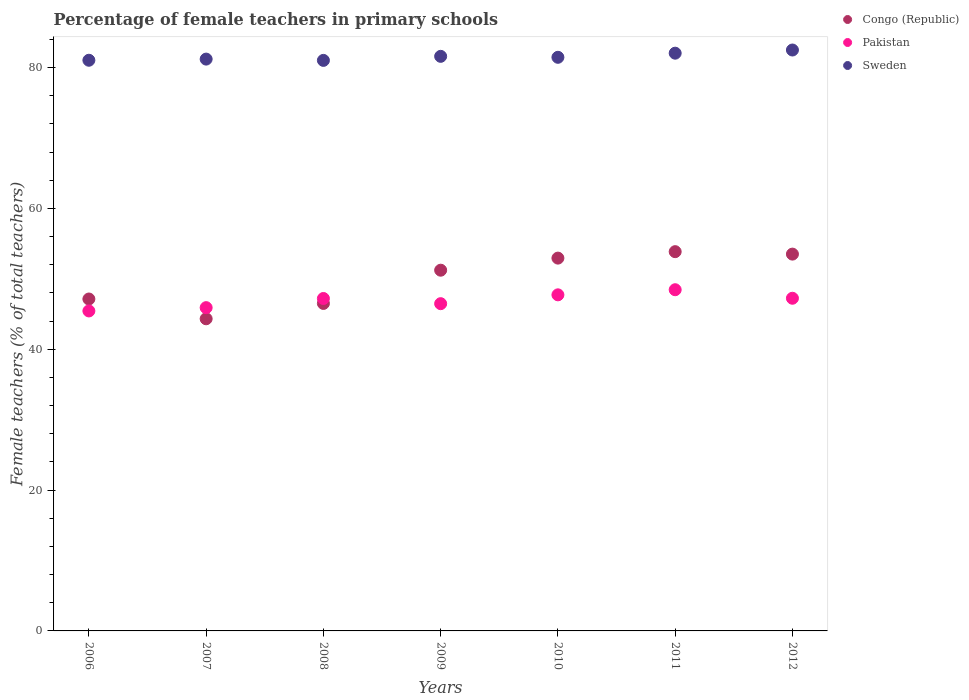What is the percentage of female teachers in Sweden in 2009?
Give a very brief answer. 81.59. Across all years, what is the maximum percentage of female teachers in Congo (Republic)?
Keep it short and to the point. 53.85. Across all years, what is the minimum percentage of female teachers in Pakistan?
Your answer should be compact. 45.44. What is the total percentage of female teachers in Sweden in the graph?
Keep it short and to the point. 570.81. What is the difference between the percentage of female teachers in Pakistan in 2006 and that in 2008?
Make the answer very short. -1.77. What is the difference between the percentage of female teachers in Pakistan in 2006 and the percentage of female teachers in Sweden in 2008?
Keep it short and to the point. -35.58. What is the average percentage of female teachers in Pakistan per year?
Ensure brevity in your answer.  46.92. In the year 2012, what is the difference between the percentage of female teachers in Sweden and percentage of female teachers in Congo (Republic)?
Your response must be concise. 28.98. In how many years, is the percentage of female teachers in Pakistan greater than 64 %?
Offer a terse response. 0. What is the ratio of the percentage of female teachers in Pakistan in 2006 to that in 2012?
Keep it short and to the point. 0.96. Is the percentage of female teachers in Pakistan in 2006 less than that in 2007?
Your answer should be compact. Yes. What is the difference between the highest and the second highest percentage of female teachers in Sweden?
Make the answer very short. 0.45. What is the difference between the highest and the lowest percentage of female teachers in Pakistan?
Your answer should be very brief. 3.01. Is the sum of the percentage of female teachers in Congo (Republic) in 2007 and 2008 greater than the maximum percentage of female teachers in Sweden across all years?
Offer a very short reply. Yes. Is it the case that in every year, the sum of the percentage of female teachers in Sweden and percentage of female teachers in Pakistan  is greater than the percentage of female teachers in Congo (Republic)?
Give a very brief answer. Yes. Does the percentage of female teachers in Sweden monotonically increase over the years?
Provide a short and direct response. No. How many dotlines are there?
Offer a very short reply. 3. What is the difference between two consecutive major ticks on the Y-axis?
Your answer should be compact. 20. Does the graph contain any zero values?
Your answer should be very brief. No. Does the graph contain grids?
Give a very brief answer. No. How many legend labels are there?
Provide a short and direct response. 3. What is the title of the graph?
Your answer should be compact. Percentage of female teachers in primary schools. What is the label or title of the X-axis?
Your answer should be very brief. Years. What is the label or title of the Y-axis?
Give a very brief answer. Female teachers (% of total teachers). What is the Female teachers (% of total teachers) in Congo (Republic) in 2006?
Keep it short and to the point. 47.13. What is the Female teachers (% of total teachers) in Pakistan in 2006?
Your answer should be compact. 45.44. What is the Female teachers (% of total teachers) in Sweden in 2006?
Your answer should be very brief. 81.03. What is the Female teachers (% of total teachers) in Congo (Republic) in 2007?
Give a very brief answer. 44.32. What is the Female teachers (% of total teachers) in Pakistan in 2007?
Give a very brief answer. 45.9. What is the Female teachers (% of total teachers) of Sweden in 2007?
Provide a succinct answer. 81.2. What is the Female teachers (% of total teachers) of Congo (Republic) in 2008?
Give a very brief answer. 46.5. What is the Female teachers (% of total teachers) in Pakistan in 2008?
Your answer should be compact. 47.2. What is the Female teachers (% of total teachers) in Sweden in 2008?
Your response must be concise. 81.01. What is the Female teachers (% of total teachers) of Congo (Republic) in 2009?
Keep it short and to the point. 51.22. What is the Female teachers (% of total teachers) of Pakistan in 2009?
Offer a terse response. 46.47. What is the Female teachers (% of total teachers) of Sweden in 2009?
Provide a succinct answer. 81.59. What is the Female teachers (% of total teachers) in Congo (Republic) in 2010?
Offer a terse response. 52.94. What is the Female teachers (% of total teachers) in Pakistan in 2010?
Keep it short and to the point. 47.72. What is the Female teachers (% of total teachers) in Sweden in 2010?
Your answer should be compact. 81.45. What is the Female teachers (% of total teachers) in Congo (Republic) in 2011?
Your answer should be compact. 53.85. What is the Female teachers (% of total teachers) in Pakistan in 2011?
Offer a terse response. 48.45. What is the Female teachers (% of total teachers) of Sweden in 2011?
Make the answer very short. 82.04. What is the Female teachers (% of total teachers) in Congo (Republic) in 2012?
Keep it short and to the point. 53.51. What is the Female teachers (% of total teachers) of Pakistan in 2012?
Offer a terse response. 47.24. What is the Female teachers (% of total teachers) of Sweden in 2012?
Offer a very short reply. 82.49. Across all years, what is the maximum Female teachers (% of total teachers) in Congo (Republic)?
Make the answer very short. 53.85. Across all years, what is the maximum Female teachers (% of total teachers) in Pakistan?
Ensure brevity in your answer.  48.45. Across all years, what is the maximum Female teachers (% of total teachers) in Sweden?
Ensure brevity in your answer.  82.49. Across all years, what is the minimum Female teachers (% of total teachers) in Congo (Republic)?
Give a very brief answer. 44.32. Across all years, what is the minimum Female teachers (% of total teachers) of Pakistan?
Keep it short and to the point. 45.44. Across all years, what is the minimum Female teachers (% of total teachers) in Sweden?
Your answer should be compact. 81.01. What is the total Female teachers (% of total teachers) of Congo (Republic) in the graph?
Your response must be concise. 349.48. What is the total Female teachers (% of total teachers) of Pakistan in the graph?
Offer a very short reply. 328.42. What is the total Female teachers (% of total teachers) in Sweden in the graph?
Your answer should be compact. 570.81. What is the difference between the Female teachers (% of total teachers) in Congo (Republic) in 2006 and that in 2007?
Your answer should be very brief. 2.81. What is the difference between the Female teachers (% of total teachers) in Pakistan in 2006 and that in 2007?
Offer a terse response. -0.47. What is the difference between the Female teachers (% of total teachers) in Sweden in 2006 and that in 2007?
Your answer should be very brief. -0.16. What is the difference between the Female teachers (% of total teachers) in Congo (Republic) in 2006 and that in 2008?
Provide a short and direct response. 0.63. What is the difference between the Female teachers (% of total teachers) of Pakistan in 2006 and that in 2008?
Give a very brief answer. -1.77. What is the difference between the Female teachers (% of total teachers) in Sweden in 2006 and that in 2008?
Provide a succinct answer. 0.02. What is the difference between the Female teachers (% of total teachers) of Congo (Republic) in 2006 and that in 2009?
Give a very brief answer. -4.09. What is the difference between the Female teachers (% of total teachers) in Pakistan in 2006 and that in 2009?
Ensure brevity in your answer.  -1.03. What is the difference between the Female teachers (% of total teachers) in Sweden in 2006 and that in 2009?
Your answer should be very brief. -0.56. What is the difference between the Female teachers (% of total teachers) of Congo (Republic) in 2006 and that in 2010?
Ensure brevity in your answer.  -5.81. What is the difference between the Female teachers (% of total teachers) of Pakistan in 2006 and that in 2010?
Your answer should be very brief. -2.29. What is the difference between the Female teachers (% of total teachers) in Sweden in 2006 and that in 2010?
Keep it short and to the point. -0.42. What is the difference between the Female teachers (% of total teachers) in Congo (Republic) in 2006 and that in 2011?
Make the answer very short. -6.72. What is the difference between the Female teachers (% of total teachers) of Pakistan in 2006 and that in 2011?
Your response must be concise. -3.01. What is the difference between the Female teachers (% of total teachers) in Sweden in 2006 and that in 2011?
Provide a short and direct response. -1. What is the difference between the Female teachers (% of total teachers) in Congo (Republic) in 2006 and that in 2012?
Provide a succinct answer. -6.37. What is the difference between the Female teachers (% of total teachers) of Pakistan in 2006 and that in 2012?
Offer a very short reply. -1.8. What is the difference between the Female teachers (% of total teachers) of Sweden in 2006 and that in 2012?
Keep it short and to the point. -1.45. What is the difference between the Female teachers (% of total teachers) of Congo (Republic) in 2007 and that in 2008?
Keep it short and to the point. -2.18. What is the difference between the Female teachers (% of total teachers) of Pakistan in 2007 and that in 2008?
Make the answer very short. -1.3. What is the difference between the Female teachers (% of total teachers) of Sweden in 2007 and that in 2008?
Your response must be concise. 0.18. What is the difference between the Female teachers (% of total teachers) in Congo (Republic) in 2007 and that in 2009?
Make the answer very short. -6.9. What is the difference between the Female teachers (% of total teachers) in Pakistan in 2007 and that in 2009?
Provide a short and direct response. -0.56. What is the difference between the Female teachers (% of total teachers) of Sweden in 2007 and that in 2009?
Your answer should be very brief. -0.39. What is the difference between the Female teachers (% of total teachers) of Congo (Republic) in 2007 and that in 2010?
Your answer should be very brief. -8.61. What is the difference between the Female teachers (% of total teachers) of Pakistan in 2007 and that in 2010?
Give a very brief answer. -1.82. What is the difference between the Female teachers (% of total teachers) of Sweden in 2007 and that in 2010?
Your answer should be very brief. -0.26. What is the difference between the Female teachers (% of total teachers) of Congo (Republic) in 2007 and that in 2011?
Provide a short and direct response. -9.53. What is the difference between the Female teachers (% of total teachers) in Pakistan in 2007 and that in 2011?
Ensure brevity in your answer.  -2.54. What is the difference between the Female teachers (% of total teachers) in Sweden in 2007 and that in 2011?
Make the answer very short. -0.84. What is the difference between the Female teachers (% of total teachers) in Congo (Republic) in 2007 and that in 2012?
Provide a short and direct response. -9.18. What is the difference between the Female teachers (% of total teachers) in Pakistan in 2007 and that in 2012?
Keep it short and to the point. -1.33. What is the difference between the Female teachers (% of total teachers) in Sweden in 2007 and that in 2012?
Your answer should be compact. -1.29. What is the difference between the Female teachers (% of total teachers) of Congo (Republic) in 2008 and that in 2009?
Provide a succinct answer. -4.72. What is the difference between the Female teachers (% of total teachers) of Pakistan in 2008 and that in 2009?
Offer a very short reply. 0.74. What is the difference between the Female teachers (% of total teachers) of Sweden in 2008 and that in 2009?
Offer a terse response. -0.57. What is the difference between the Female teachers (% of total teachers) of Congo (Republic) in 2008 and that in 2010?
Your answer should be very brief. -6.44. What is the difference between the Female teachers (% of total teachers) of Pakistan in 2008 and that in 2010?
Offer a very short reply. -0.52. What is the difference between the Female teachers (% of total teachers) in Sweden in 2008 and that in 2010?
Make the answer very short. -0.44. What is the difference between the Female teachers (% of total teachers) in Congo (Republic) in 2008 and that in 2011?
Offer a very short reply. -7.35. What is the difference between the Female teachers (% of total teachers) of Pakistan in 2008 and that in 2011?
Ensure brevity in your answer.  -1.25. What is the difference between the Female teachers (% of total teachers) in Sweden in 2008 and that in 2011?
Keep it short and to the point. -1.02. What is the difference between the Female teachers (% of total teachers) in Congo (Republic) in 2008 and that in 2012?
Provide a short and direct response. -7. What is the difference between the Female teachers (% of total teachers) in Pakistan in 2008 and that in 2012?
Ensure brevity in your answer.  -0.03. What is the difference between the Female teachers (% of total teachers) in Sweden in 2008 and that in 2012?
Your response must be concise. -1.47. What is the difference between the Female teachers (% of total teachers) of Congo (Republic) in 2009 and that in 2010?
Make the answer very short. -1.72. What is the difference between the Female teachers (% of total teachers) in Pakistan in 2009 and that in 2010?
Offer a very short reply. -1.26. What is the difference between the Female teachers (% of total teachers) in Sweden in 2009 and that in 2010?
Your answer should be compact. 0.14. What is the difference between the Female teachers (% of total teachers) in Congo (Republic) in 2009 and that in 2011?
Make the answer very short. -2.63. What is the difference between the Female teachers (% of total teachers) of Pakistan in 2009 and that in 2011?
Offer a very short reply. -1.98. What is the difference between the Female teachers (% of total teachers) of Sweden in 2009 and that in 2011?
Give a very brief answer. -0.45. What is the difference between the Female teachers (% of total teachers) of Congo (Republic) in 2009 and that in 2012?
Provide a succinct answer. -2.28. What is the difference between the Female teachers (% of total teachers) of Pakistan in 2009 and that in 2012?
Your answer should be compact. -0.77. What is the difference between the Female teachers (% of total teachers) in Sweden in 2009 and that in 2012?
Keep it short and to the point. -0.9. What is the difference between the Female teachers (% of total teachers) in Congo (Republic) in 2010 and that in 2011?
Give a very brief answer. -0.92. What is the difference between the Female teachers (% of total teachers) in Pakistan in 2010 and that in 2011?
Make the answer very short. -0.73. What is the difference between the Female teachers (% of total teachers) in Sweden in 2010 and that in 2011?
Make the answer very short. -0.58. What is the difference between the Female teachers (% of total teachers) in Congo (Republic) in 2010 and that in 2012?
Offer a very short reply. -0.57. What is the difference between the Female teachers (% of total teachers) of Pakistan in 2010 and that in 2012?
Your response must be concise. 0.49. What is the difference between the Female teachers (% of total teachers) of Sweden in 2010 and that in 2012?
Your answer should be compact. -1.04. What is the difference between the Female teachers (% of total teachers) in Congo (Republic) in 2011 and that in 2012?
Keep it short and to the point. 0.35. What is the difference between the Female teachers (% of total teachers) of Pakistan in 2011 and that in 2012?
Keep it short and to the point. 1.21. What is the difference between the Female teachers (% of total teachers) of Sweden in 2011 and that in 2012?
Keep it short and to the point. -0.45. What is the difference between the Female teachers (% of total teachers) of Congo (Republic) in 2006 and the Female teachers (% of total teachers) of Pakistan in 2007?
Ensure brevity in your answer.  1.23. What is the difference between the Female teachers (% of total teachers) of Congo (Republic) in 2006 and the Female teachers (% of total teachers) of Sweden in 2007?
Your answer should be very brief. -34.07. What is the difference between the Female teachers (% of total teachers) in Pakistan in 2006 and the Female teachers (% of total teachers) in Sweden in 2007?
Keep it short and to the point. -35.76. What is the difference between the Female teachers (% of total teachers) in Congo (Republic) in 2006 and the Female teachers (% of total teachers) in Pakistan in 2008?
Provide a short and direct response. -0.07. What is the difference between the Female teachers (% of total teachers) in Congo (Republic) in 2006 and the Female teachers (% of total teachers) in Sweden in 2008?
Give a very brief answer. -33.88. What is the difference between the Female teachers (% of total teachers) in Pakistan in 2006 and the Female teachers (% of total teachers) in Sweden in 2008?
Your answer should be very brief. -35.58. What is the difference between the Female teachers (% of total teachers) in Congo (Republic) in 2006 and the Female teachers (% of total teachers) in Pakistan in 2009?
Your answer should be compact. 0.66. What is the difference between the Female teachers (% of total teachers) in Congo (Republic) in 2006 and the Female teachers (% of total teachers) in Sweden in 2009?
Your answer should be very brief. -34.46. What is the difference between the Female teachers (% of total teachers) of Pakistan in 2006 and the Female teachers (% of total teachers) of Sweden in 2009?
Ensure brevity in your answer.  -36.15. What is the difference between the Female teachers (% of total teachers) of Congo (Republic) in 2006 and the Female teachers (% of total teachers) of Pakistan in 2010?
Provide a short and direct response. -0.59. What is the difference between the Female teachers (% of total teachers) of Congo (Republic) in 2006 and the Female teachers (% of total teachers) of Sweden in 2010?
Offer a very short reply. -34.32. What is the difference between the Female teachers (% of total teachers) of Pakistan in 2006 and the Female teachers (% of total teachers) of Sweden in 2010?
Give a very brief answer. -36.02. What is the difference between the Female teachers (% of total teachers) of Congo (Republic) in 2006 and the Female teachers (% of total teachers) of Pakistan in 2011?
Make the answer very short. -1.32. What is the difference between the Female teachers (% of total teachers) in Congo (Republic) in 2006 and the Female teachers (% of total teachers) in Sweden in 2011?
Provide a succinct answer. -34.91. What is the difference between the Female teachers (% of total teachers) in Pakistan in 2006 and the Female teachers (% of total teachers) in Sweden in 2011?
Give a very brief answer. -36.6. What is the difference between the Female teachers (% of total teachers) in Congo (Republic) in 2006 and the Female teachers (% of total teachers) in Pakistan in 2012?
Offer a terse response. -0.11. What is the difference between the Female teachers (% of total teachers) of Congo (Republic) in 2006 and the Female teachers (% of total teachers) of Sweden in 2012?
Your response must be concise. -35.36. What is the difference between the Female teachers (% of total teachers) in Pakistan in 2006 and the Female teachers (% of total teachers) in Sweden in 2012?
Your answer should be very brief. -37.05. What is the difference between the Female teachers (% of total teachers) in Congo (Republic) in 2007 and the Female teachers (% of total teachers) in Pakistan in 2008?
Offer a terse response. -2.88. What is the difference between the Female teachers (% of total teachers) in Congo (Republic) in 2007 and the Female teachers (% of total teachers) in Sweden in 2008?
Offer a terse response. -36.69. What is the difference between the Female teachers (% of total teachers) of Pakistan in 2007 and the Female teachers (% of total teachers) of Sweden in 2008?
Provide a succinct answer. -35.11. What is the difference between the Female teachers (% of total teachers) of Congo (Republic) in 2007 and the Female teachers (% of total teachers) of Pakistan in 2009?
Give a very brief answer. -2.15. What is the difference between the Female teachers (% of total teachers) in Congo (Republic) in 2007 and the Female teachers (% of total teachers) in Sweden in 2009?
Offer a very short reply. -37.27. What is the difference between the Female teachers (% of total teachers) in Pakistan in 2007 and the Female teachers (% of total teachers) in Sweden in 2009?
Your answer should be compact. -35.68. What is the difference between the Female teachers (% of total teachers) in Congo (Republic) in 2007 and the Female teachers (% of total teachers) in Pakistan in 2010?
Keep it short and to the point. -3.4. What is the difference between the Female teachers (% of total teachers) of Congo (Republic) in 2007 and the Female teachers (% of total teachers) of Sweden in 2010?
Your answer should be compact. -37.13. What is the difference between the Female teachers (% of total teachers) of Pakistan in 2007 and the Female teachers (% of total teachers) of Sweden in 2010?
Make the answer very short. -35.55. What is the difference between the Female teachers (% of total teachers) in Congo (Republic) in 2007 and the Female teachers (% of total teachers) in Pakistan in 2011?
Your answer should be compact. -4.13. What is the difference between the Female teachers (% of total teachers) in Congo (Republic) in 2007 and the Female teachers (% of total teachers) in Sweden in 2011?
Your answer should be compact. -37.71. What is the difference between the Female teachers (% of total teachers) in Pakistan in 2007 and the Female teachers (% of total teachers) in Sweden in 2011?
Give a very brief answer. -36.13. What is the difference between the Female teachers (% of total teachers) of Congo (Republic) in 2007 and the Female teachers (% of total teachers) of Pakistan in 2012?
Provide a succinct answer. -2.92. What is the difference between the Female teachers (% of total teachers) in Congo (Republic) in 2007 and the Female teachers (% of total teachers) in Sweden in 2012?
Your response must be concise. -38.16. What is the difference between the Female teachers (% of total teachers) in Pakistan in 2007 and the Female teachers (% of total teachers) in Sweden in 2012?
Your response must be concise. -36.58. What is the difference between the Female teachers (% of total teachers) in Congo (Republic) in 2008 and the Female teachers (% of total teachers) in Pakistan in 2009?
Ensure brevity in your answer.  0.03. What is the difference between the Female teachers (% of total teachers) in Congo (Republic) in 2008 and the Female teachers (% of total teachers) in Sweden in 2009?
Provide a short and direct response. -35.09. What is the difference between the Female teachers (% of total teachers) of Pakistan in 2008 and the Female teachers (% of total teachers) of Sweden in 2009?
Ensure brevity in your answer.  -34.39. What is the difference between the Female teachers (% of total teachers) of Congo (Republic) in 2008 and the Female teachers (% of total teachers) of Pakistan in 2010?
Provide a short and direct response. -1.22. What is the difference between the Female teachers (% of total teachers) of Congo (Republic) in 2008 and the Female teachers (% of total teachers) of Sweden in 2010?
Offer a very short reply. -34.95. What is the difference between the Female teachers (% of total teachers) in Pakistan in 2008 and the Female teachers (% of total teachers) in Sweden in 2010?
Offer a very short reply. -34.25. What is the difference between the Female teachers (% of total teachers) of Congo (Republic) in 2008 and the Female teachers (% of total teachers) of Pakistan in 2011?
Make the answer very short. -1.95. What is the difference between the Female teachers (% of total teachers) in Congo (Republic) in 2008 and the Female teachers (% of total teachers) in Sweden in 2011?
Offer a terse response. -35.53. What is the difference between the Female teachers (% of total teachers) in Pakistan in 2008 and the Female teachers (% of total teachers) in Sweden in 2011?
Provide a succinct answer. -34.83. What is the difference between the Female teachers (% of total teachers) of Congo (Republic) in 2008 and the Female teachers (% of total teachers) of Pakistan in 2012?
Give a very brief answer. -0.74. What is the difference between the Female teachers (% of total teachers) of Congo (Republic) in 2008 and the Female teachers (% of total teachers) of Sweden in 2012?
Offer a very short reply. -35.98. What is the difference between the Female teachers (% of total teachers) in Pakistan in 2008 and the Female teachers (% of total teachers) in Sweden in 2012?
Ensure brevity in your answer.  -35.28. What is the difference between the Female teachers (% of total teachers) of Congo (Republic) in 2009 and the Female teachers (% of total teachers) of Pakistan in 2010?
Offer a terse response. 3.5. What is the difference between the Female teachers (% of total teachers) of Congo (Republic) in 2009 and the Female teachers (% of total teachers) of Sweden in 2010?
Keep it short and to the point. -30.23. What is the difference between the Female teachers (% of total teachers) of Pakistan in 2009 and the Female teachers (% of total teachers) of Sweden in 2010?
Keep it short and to the point. -34.98. What is the difference between the Female teachers (% of total teachers) of Congo (Republic) in 2009 and the Female teachers (% of total teachers) of Pakistan in 2011?
Offer a very short reply. 2.77. What is the difference between the Female teachers (% of total teachers) in Congo (Republic) in 2009 and the Female teachers (% of total teachers) in Sweden in 2011?
Provide a short and direct response. -30.82. What is the difference between the Female teachers (% of total teachers) of Pakistan in 2009 and the Female teachers (% of total teachers) of Sweden in 2011?
Your answer should be very brief. -35.57. What is the difference between the Female teachers (% of total teachers) in Congo (Republic) in 2009 and the Female teachers (% of total teachers) in Pakistan in 2012?
Ensure brevity in your answer.  3.98. What is the difference between the Female teachers (% of total teachers) in Congo (Republic) in 2009 and the Female teachers (% of total teachers) in Sweden in 2012?
Your answer should be compact. -31.27. What is the difference between the Female teachers (% of total teachers) in Pakistan in 2009 and the Female teachers (% of total teachers) in Sweden in 2012?
Ensure brevity in your answer.  -36.02. What is the difference between the Female teachers (% of total teachers) in Congo (Republic) in 2010 and the Female teachers (% of total teachers) in Pakistan in 2011?
Make the answer very short. 4.49. What is the difference between the Female teachers (% of total teachers) of Congo (Republic) in 2010 and the Female teachers (% of total teachers) of Sweden in 2011?
Offer a terse response. -29.1. What is the difference between the Female teachers (% of total teachers) in Pakistan in 2010 and the Female teachers (% of total teachers) in Sweden in 2011?
Your response must be concise. -34.31. What is the difference between the Female teachers (% of total teachers) in Congo (Republic) in 2010 and the Female teachers (% of total teachers) in Pakistan in 2012?
Keep it short and to the point. 5.7. What is the difference between the Female teachers (% of total teachers) of Congo (Republic) in 2010 and the Female teachers (% of total teachers) of Sweden in 2012?
Keep it short and to the point. -29.55. What is the difference between the Female teachers (% of total teachers) of Pakistan in 2010 and the Female teachers (% of total teachers) of Sweden in 2012?
Keep it short and to the point. -34.76. What is the difference between the Female teachers (% of total teachers) in Congo (Republic) in 2011 and the Female teachers (% of total teachers) in Pakistan in 2012?
Make the answer very short. 6.62. What is the difference between the Female teachers (% of total teachers) in Congo (Republic) in 2011 and the Female teachers (% of total teachers) in Sweden in 2012?
Your answer should be very brief. -28.63. What is the difference between the Female teachers (% of total teachers) of Pakistan in 2011 and the Female teachers (% of total teachers) of Sweden in 2012?
Ensure brevity in your answer.  -34.04. What is the average Female teachers (% of total teachers) of Congo (Republic) per year?
Ensure brevity in your answer.  49.93. What is the average Female teachers (% of total teachers) of Pakistan per year?
Give a very brief answer. 46.92. What is the average Female teachers (% of total teachers) in Sweden per year?
Provide a succinct answer. 81.54. In the year 2006, what is the difference between the Female teachers (% of total teachers) in Congo (Republic) and Female teachers (% of total teachers) in Pakistan?
Your response must be concise. 1.7. In the year 2006, what is the difference between the Female teachers (% of total teachers) of Congo (Republic) and Female teachers (% of total teachers) of Sweden?
Your answer should be compact. -33.9. In the year 2006, what is the difference between the Female teachers (% of total teachers) of Pakistan and Female teachers (% of total teachers) of Sweden?
Your answer should be compact. -35.6. In the year 2007, what is the difference between the Female teachers (% of total teachers) of Congo (Republic) and Female teachers (% of total teachers) of Pakistan?
Your answer should be very brief. -1.58. In the year 2007, what is the difference between the Female teachers (% of total teachers) in Congo (Republic) and Female teachers (% of total teachers) in Sweden?
Offer a terse response. -36.87. In the year 2007, what is the difference between the Female teachers (% of total teachers) in Pakistan and Female teachers (% of total teachers) in Sweden?
Your response must be concise. -35.29. In the year 2008, what is the difference between the Female teachers (% of total teachers) of Congo (Republic) and Female teachers (% of total teachers) of Pakistan?
Your answer should be compact. -0.7. In the year 2008, what is the difference between the Female teachers (% of total teachers) of Congo (Republic) and Female teachers (% of total teachers) of Sweden?
Ensure brevity in your answer.  -34.51. In the year 2008, what is the difference between the Female teachers (% of total teachers) in Pakistan and Female teachers (% of total teachers) in Sweden?
Provide a succinct answer. -33.81. In the year 2009, what is the difference between the Female teachers (% of total teachers) of Congo (Republic) and Female teachers (% of total teachers) of Pakistan?
Ensure brevity in your answer.  4.75. In the year 2009, what is the difference between the Female teachers (% of total teachers) of Congo (Republic) and Female teachers (% of total teachers) of Sweden?
Your response must be concise. -30.37. In the year 2009, what is the difference between the Female teachers (% of total teachers) of Pakistan and Female teachers (% of total teachers) of Sweden?
Your response must be concise. -35.12. In the year 2010, what is the difference between the Female teachers (% of total teachers) in Congo (Republic) and Female teachers (% of total teachers) in Pakistan?
Ensure brevity in your answer.  5.21. In the year 2010, what is the difference between the Female teachers (% of total teachers) of Congo (Republic) and Female teachers (% of total teachers) of Sweden?
Give a very brief answer. -28.51. In the year 2010, what is the difference between the Female teachers (% of total teachers) of Pakistan and Female teachers (% of total teachers) of Sweden?
Your answer should be very brief. -33.73. In the year 2011, what is the difference between the Female teachers (% of total teachers) of Congo (Republic) and Female teachers (% of total teachers) of Pakistan?
Ensure brevity in your answer.  5.41. In the year 2011, what is the difference between the Female teachers (% of total teachers) in Congo (Republic) and Female teachers (% of total teachers) in Sweden?
Your answer should be very brief. -28.18. In the year 2011, what is the difference between the Female teachers (% of total teachers) of Pakistan and Female teachers (% of total teachers) of Sweden?
Offer a terse response. -33.59. In the year 2012, what is the difference between the Female teachers (% of total teachers) in Congo (Republic) and Female teachers (% of total teachers) in Pakistan?
Offer a terse response. 6.27. In the year 2012, what is the difference between the Female teachers (% of total teachers) in Congo (Republic) and Female teachers (% of total teachers) in Sweden?
Provide a short and direct response. -28.98. In the year 2012, what is the difference between the Female teachers (% of total teachers) of Pakistan and Female teachers (% of total teachers) of Sweden?
Keep it short and to the point. -35.25. What is the ratio of the Female teachers (% of total teachers) in Congo (Republic) in 2006 to that in 2007?
Your answer should be compact. 1.06. What is the ratio of the Female teachers (% of total teachers) of Congo (Republic) in 2006 to that in 2008?
Make the answer very short. 1.01. What is the ratio of the Female teachers (% of total teachers) of Pakistan in 2006 to that in 2008?
Your answer should be very brief. 0.96. What is the ratio of the Female teachers (% of total teachers) in Congo (Republic) in 2006 to that in 2009?
Give a very brief answer. 0.92. What is the ratio of the Female teachers (% of total teachers) of Pakistan in 2006 to that in 2009?
Offer a terse response. 0.98. What is the ratio of the Female teachers (% of total teachers) of Congo (Republic) in 2006 to that in 2010?
Make the answer very short. 0.89. What is the ratio of the Female teachers (% of total teachers) of Pakistan in 2006 to that in 2010?
Keep it short and to the point. 0.95. What is the ratio of the Female teachers (% of total teachers) of Sweden in 2006 to that in 2010?
Provide a short and direct response. 0.99. What is the ratio of the Female teachers (% of total teachers) of Congo (Republic) in 2006 to that in 2011?
Offer a terse response. 0.88. What is the ratio of the Female teachers (% of total teachers) of Pakistan in 2006 to that in 2011?
Offer a very short reply. 0.94. What is the ratio of the Female teachers (% of total teachers) in Sweden in 2006 to that in 2011?
Provide a short and direct response. 0.99. What is the ratio of the Female teachers (% of total teachers) of Congo (Republic) in 2006 to that in 2012?
Make the answer very short. 0.88. What is the ratio of the Female teachers (% of total teachers) of Pakistan in 2006 to that in 2012?
Offer a very short reply. 0.96. What is the ratio of the Female teachers (% of total teachers) in Sweden in 2006 to that in 2012?
Keep it short and to the point. 0.98. What is the ratio of the Female teachers (% of total teachers) of Congo (Republic) in 2007 to that in 2008?
Ensure brevity in your answer.  0.95. What is the ratio of the Female teachers (% of total teachers) of Pakistan in 2007 to that in 2008?
Provide a short and direct response. 0.97. What is the ratio of the Female teachers (% of total teachers) in Sweden in 2007 to that in 2008?
Provide a short and direct response. 1. What is the ratio of the Female teachers (% of total teachers) in Congo (Republic) in 2007 to that in 2009?
Ensure brevity in your answer.  0.87. What is the ratio of the Female teachers (% of total teachers) in Pakistan in 2007 to that in 2009?
Ensure brevity in your answer.  0.99. What is the ratio of the Female teachers (% of total teachers) in Sweden in 2007 to that in 2009?
Provide a short and direct response. 1. What is the ratio of the Female teachers (% of total teachers) in Congo (Republic) in 2007 to that in 2010?
Provide a short and direct response. 0.84. What is the ratio of the Female teachers (% of total teachers) of Pakistan in 2007 to that in 2010?
Offer a very short reply. 0.96. What is the ratio of the Female teachers (% of total teachers) of Sweden in 2007 to that in 2010?
Offer a terse response. 1. What is the ratio of the Female teachers (% of total teachers) of Congo (Republic) in 2007 to that in 2011?
Keep it short and to the point. 0.82. What is the ratio of the Female teachers (% of total teachers) in Pakistan in 2007 to that in 2011?
Provide a short and direct response. 0.95. What is the ratio of the Female teachers (% of total teachers) in Congo (Republic) in 2007 to that in 2012?
Your response must be concise. 0.83. What is the ratio of the Female teachers (% of total teachers) in Pakistan in 2007 to that in 2012?
Keep it short and to the point. 0.97. What is the ratio of the Female teachers (% of total teachers) in Sweden in 2007 to that in 2012?
Your answer should be compact. 0.98. What is the ratio of the Female teachers (% of total teachers) in Congo (Republic) in 2008 to that in 2009?
Provide a short and direct response. 0.91. What is the ratio of the Female teachers (% of total teachers) of Pakistan in 2008 to that in 2009?
Keep it short and to the point. 1.02. What is the ratio of the Female teachers (% of total teachers) of Sweden in 2008 to that in 2009?
Offer a terse response. 0.99. What is the ratio of the Female teachers (% of total teachers) of Congo (Republic) in 2008 to that in 2010?
Ensure brevity in your answer.  0.88. What is the ratio of the Female teachers (% of total teachers) of Congo (Republic) in 2008 to that in 2011?
Provide a short and direct response. 0.86. What is the ratio of the Female teachers (% of total teachers) in Pakistan in 2008 to that in 2011?
Your answer should be compact. 0.97. What is the ratio of the Female teachers (% of total teachers) in Sweden in 2008 to that in 2011?
Provide a succinct answer. 0.99. What is the ratio of the Female teachers (% of total teachers) of Congo (Republic) in 2008 to that in 2012?
Offer a very short reply. 0.87. What is the ratio of the Female teachers (% of total teachers) of Sweden in 2008 to that in 2012?
Your answer should be compact. 0.98. What is the ratio of the Female teachers (% of total teachers) of Congo (Republic) in 2009 to that in 2010?
Ensure brevity in your answer.  0.97. What is the ratio of the Female teachers (% of total teachers) in Pakistan in 2009 to that in 2010?
Your response must be concise. 0.97. What is the ratio of the Female teachers (% of total teachers) of Congo (Republic) in 2009 to that in 2011?
Provide a succinct answer. 0.95. What is the ratio of the Female teachers (% of total teachers) in Pakistan in 2009 to that in 2011?
Ensure brevity in your answer.  0.96. What is the ratio of the Female teachers (% of total teachers) of Sweden in 2009 to that in 2011?
Make the answer very short. 0.99. What is the ratio of the Female teachers (% of total teachers) in Congo (Republic) in 2009 to that in 2012?
Provide a short and direct response. 0.96. What is the ratio of the Female teachers (% of total teachers) in Pakistan in 2009 to that in 2012?
Your answer should be very brief. 0.98. What is the ratio of the Female teachers (% of total teachers) of Sweden in 2009 to that in 2012?
Make the answer very short. 0.99. What is the ratio of the Female teachers (% of total teachers) in Pakistan in 2010 to that in 2011?
Keep it short and to the point. 0.98. What is the ratio of the Female teachers (% of total teachers) in Congo (Republic) in 2010 to that in 2012?
Ensure brevity in your answer.  0.99. What is the ratio of the Female teachers (% of total teachers) in Pakistan in 2010 to that in 2012?
Offer a very short reply. 1.01. What is the ratio of the Female teachers (% of total teachers) of Sweden in 2010 to that in 2012?
Provide a succinct answer. 0.99. What is the ratio of the Female teachers (% of total teachers) in Pakistan in 2011 to that in 2012?
Offer a very short reply. 1.03. What is the ratio of the Female teachers (% of total teachers) of Sweden in 2011 to that in 2012?
Your response must be concise. 0.99. What is the difference between the highest and the second highest Female teachers (% of total teachers) of Congo (Republic)?
Make the answer very short. 0.35. What is the difference between the highest and the second highest Female teachers (% of total teachers) of Pakistan?
Provide a succinct answer. 0.73. What is the difference between the highest and the second highest Female teachers (% of total teachers) in Sweden?
Offer a very short reply. 0.45. What is the difference between the highest and the lowest Female teachers (% of total teachers) in Congo (Republic)?
Ensure brevity in your answer.  9.53. What is the difference between the highest and the lowest Female teachers (% of total teachers) of Pakistan?
Offer a very short reply. 3.01. What is the difference between the highest and the lowest Female teachers (% of total teachers) of Sweden?
Ensure brevity in your answer.  1.47. 